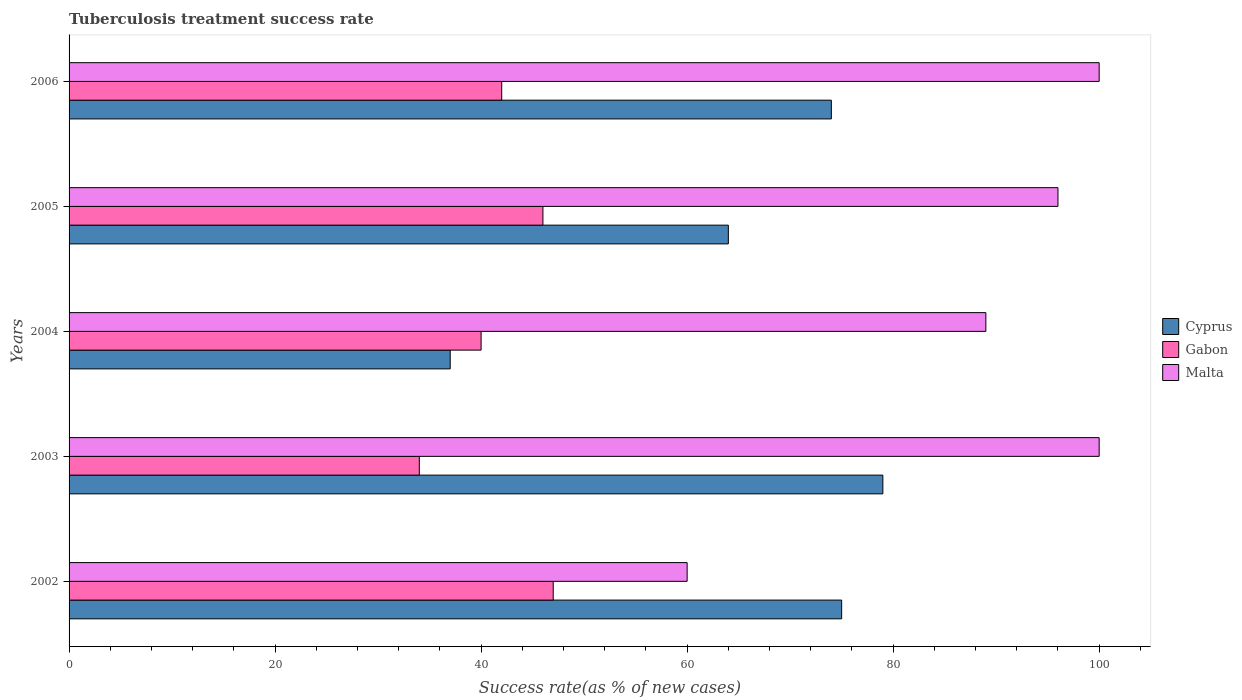How many different coloured bars are there?
Ensure brevity in your answer.  3. How many groups of bars are there?
Offer a terse response. 5. What is the label of the 2nd group of bars from the top?
Make the answer very short. 2005. What is the tuberculosis treatment success rate in Gabon in 2006?
Your answer should be compact. 42. Across all years, what is the maximum tuberculosis treatment success rate in Malta?
Offer a terse response. 100. Across all years, what is the minimum tuberculosis treatment success rate in Cyprus?
Provide a succinct answer. 37. What is the total tuberculosis treatment success rate in Malta in the graph?
Ensure brevity in your answer.  445. What is the average tuberculosis treatment success rate in Cyprus per year?
Offer a terse response. 65.8. In the year 2003, what is the difference between the tuberculosis treatment success rate in Gabon and tuberculosis treatment success rate in Malta?
Offer a terse response. -66. In how many years, is the tuberculosis treatment success rate in Gabon greater than 92 %?
Your answer should be compact. 0. What is the ratio of the tuberculosis treatment success rate in Gabon in 2004 to that in 2006?
Your answer should be very brief. 0.95. Is the tuberculosis treatment success rate in Cyprus in 2002 less than that in 2004?
Offer a very short reply. No. Is the difference between the tuberculosis treatment success rate in Gabon in 2002 and 2005 greater than the difference between the tuberculosis treatment success rate in Malta in 2002 and 2005?
Your answer should be very brief. Yes. In how many years, is the tuberculosis treatment success rate in Gabon greater than the average tuberculosis treatment success rate in Gabon taken over all years?
Provide a short and direct response. 3. What does the 2nd bar from the top in 2004 represents?
Your response must be concise. Gabon. What does the 1st bar from the bottom in 2003 represents?
Your response must be concise. Cyprus. How many bars are there?
Provide a short and direct response. 15. How many years are there in the graph?
Provide a short and direct response. 5. What is the difference between two consecutive major ticks on the X-axis?
Provide a succinct answer. 20. Are the values on the major ticks of X-axis written in scientific E-notation?
Provide a succinct answer. No. Does the graph contain grids?
Offer a very short reply. No. Where does the legend appear in the graph?
Provide a short and direct response. Center right. How many legend labels are there?
Give a very brief answer. 3. What is the title of the graph?
Your answer should be compact. Tuberculosis treatment success rate. What is the label or title of the X-axis?
Your response must be concise. Success rate(as % of new cases). What is the label or title of the Y-axis?
Offer a very short reply. Years. What is the Success rate(as % of new cases) in Cyprus in 2002?
Provide a short and direct response. 75. What is the Success rate(as % of new cases) of Cyprus in 2003?
Provide a short and direct response. 79. What is the Success rate(as % of new cases) in Cyprus in 2004?
Your response must be concise. 37. What is the Success rate(as % of new cases) of Malta in 2004?
Offer a very short reply. 89. What is the Success rate(as % of new cases) of Cyprus in 2005?
Give a very brief answer. 64. What is the Success rate(as % of new cases) in Malta in 2005?
Keep it short and to the point. 96. What is the Success rate(as % of new cases) in Cyprus in 2006?
Ensure brevity in your answer.  74. What is the Success rate(as % of new cases) in Malta in 2006?
Ensure brevity in your answer.  100. Across all years, what is the maximum Success rate(as % of new cases) of Cyprus?
Give a very brief answer. 79. Across all years, what is the maximum Success rate(as % of new cases) in Gabon?
Offer a very short reply. 47. Across all years, what is the minimum Success rate(as % of new cases) of Gabon?
Provide a short and direct response. 34. Across all years, what is the minimum Success rate(as % of new cases) in Malta?
Offer a terse response. 60. What is the total Success rate(as % of new cases) in Cyprus in the graph?
Your response must be concise. 329. What is the total Success rate(as % of new cases) in Gabon in the graph?
Your answer should be compact. 209. What is the total Success rate(as % of new cases) in Malta in the graph?
Your answer should be compact. 445. What is the difference between the Success rate(as % of new cases) in Cyprus in 2002 and that in 2003?
Your answer should be compact. -4. What is the difference between the Success rate(as % of new cases) of Gabon in 2002 and that in 2003?
Provide a succinct answer. 13. What is the difference between the Success rate(as % of new cases) in Cyprus in 2002 and that in 2004?
Your response must be concise. 38. What is the difference between the Success rate(as % of new cases) in Malta in 2002 and that in 2004?
Provide a short and direct response. -29. What is the difference between the Success rate(as % of new cases) of Cyprus in 2002 and that in 2005?
Your answer should be compact. 11. What is the difference between the Success rate(as % of new cases) in Gabon in 2002 and that in 2005?
Your answer should be very brief. 1. What is the difference between the Success rate(as % of new cases) in Malta in 2002 and that in 2005?
Ensure brevity in your answer.  -36. What is the difference between the Success rate(as % of new cases) in Cyprus in 2002 and that in 2006?
Offer a very short reply. 1. What is the difference between the Success rate(as % of new cases) of Gabon in 2002 and that in 2006?
Give a very brief answer. 5. What is the difference between the Success rate(as % of new cases) in Cyprus in 2003 and that in 2004?
Make the answer very short. 42. What is the difference between the Success rate(as % of new cases) of Cyprus in 2003 and that in 2005?
Make the answer very short. 15. What is the difference between the Success rate(as % of new cases) in Gabon in 2003 and that in 2005?
Offer a very short reply. -12. What is the difference between the Success rate(as % of new cases) of Malta in 2003 and that in 2005?
Offer a terse response. 4. What is the difference between the Success rate(as % of new cases) in Gabon in 2003 and that in 2006?
Keep it short and to the point. -8. What is the difference between the Success rate(as % of new cases) of Malta in 2003 and that in 2006?
Offer a terse response. 0. What is the difference between the Success rate(as % of new cases) in Cyprus in 2004 and that in 2005?
Your answer should be very brief. -27. What is the difference between the Success rate(as % of new cases) in Malta in 2004 and that in 2005?
Provide a short and direct response. -7. What is the difference between the Success rate(as % of new cases) of Cyprus in 2004 and that in 2006?
Keep it short and to the point. -37. What is the difference between the Success rate(as % of new cases) in Gabon in 2004 and that in 2006?
Make the answer very short. -2. What is the difference between the Success rate(as % of new cases) of Malta in 2004 and that in 2006?
Give a very brief answer. -11. What is the difference between the Success rate(as % of new cases) of Malta in 2005 and that in 2006?
Your answer should be compact. -4. What is the difference between the Success rate(as % of new cases) in Cyprus in 2002 and the Success rate(as % of new cases) in Gabon in 2003?
Ensure brevity in your answer.  41. What is the difference between the Success rate(as % of new cases) of Cyprus in 2002 and the Success rate(as % of new cases) of Malta in 2003?
Your answer should be very brief. -25. What is the difference between the Success rate(as % of new cases) of Gabon in 2002 and the Success rate(as % of new cases) of Malta in 2003?
Your answer should be compact. -53. What is the difference between the Success rate(as % of new cases) in Cyprus in 2002 and the Success rate(as % of new cases) in Gabon in 2004?
Ensure brevity in your answer.  35. What is the difference between the Success rate(as % of new cases) of Gabon in 2002 and the Success rate(as % of new cases) of Malta in 2004?
Provide a succinct answer. -42. What is the difference between the Success rate(as % of new cases) of Cyprus in 2002 and the Success rate(as % of new cases) of Gabon in 2005?
Make the answer very short. 29. What is the difference between the Success rate(as % of new cases) in Gabon in 2002 and the Success rate(as % of new cases) in Malta in 2005?
Keep it short and to the point. -49. What is the difference between the Success rate(as % of new cases) of Cyprus in 2002 and the Success rate(as % of new cases) of Gabon in 2006?
Your answer should be very brief. 33. What is the difference between the Success rate(as % of new cases) of Gabon in 2002 and the Success rate(as % of new cases) of Malta in 2006?
Your response must be concise. -53. What is the difference between the Success rate(as % of new cases) in Cyprus in 2003 and the Success rate(as % of new cases) in Gabon in 2004?
Keep it short and to the point. 39. What is the difference between the Success rate(as % of new cases) in Gabon in 2003 and the Success rate(as % of new cases) in Malta in 2004?
Provide a succinct answer. -55. What is the difference between the Success rate(as % of new cases) in Cyprus in 2003 and the Success rate(as % of new cases) in Gabon in 2005?
Offer a very short reply. 33. What is the difference between the Success rate(as % of new cases) of Cyprus in 2003 and the Success rate(as % of new cases) of Malta in 2005?
Give a very brief answer. -17. What is the difference between the Success rate(as % of new cases) of Gabon in 2003 and the Success rate(as % of new cases) of Malta in 2005?
Your response must be concise. -62. What is the difference between the Success rate(as % of new cases) of Cyprus in 2003 and the Success rate(as % of new cases) of Malta in 2006?
Your answer should be compact. -21. What is the difference between the Success rate(as % of new cases) of Gabon in 2003 and the Success rate(as % of new cases) of Malta in 2006?
Your answer should be compact. -66. What is the difference between the Success rate(as % of new cases) of Cyprus in 2004 and the Success rate(as % of new cases) of Malta in 2005?
Your response must be concise. -59. What is the difference between the Success rate(as % of new cases) in Gabon in 2004 and the Success rate(as % of new cases) in Malta in 2005?
Provide a succinct answer. -56. What is the difference between the Success rate(as % of new cases) in Cyprus in 2004 and the Success rate(as % of new cases) in Gabon in 2006?
Offer a very short reply. -5. What is the difference between the Success rate(as % of new cases) in Cyprus in 2004 and the Success rate(as % of new cases) in Malta in 2006?
Keep it short and to the point. -63. What is the difference between the Success rate(as % of new cases) of Gabon in 2004 and the Success rate(as % of new cases) of Malta in 2006?
Ensure brevity in your answer.  -60. What is the difference between the Success rate(as % of new cases) in Cyprus in 2005 and the Success rate(as % of new cases) in Gabon in 2006?
Ensure brevity in your answer.  22. What is the difference between the Success rate(as % of new cases) in Cyprus in 2005 and the Success rate(as % of new cases) in Malta in 2006?
Your response must be concise. -36. What is the difference between the Success rate(as % of new cases) of Gabon in 2005 and the Success rate(as % of new cases) of Malta in 2006?
Provide a short and direct response. -54. What is the average Success rate(as % of new cases) of Cyprus per year?
Ensure brevity in your answer.  65.8. What is the average Success rate(as % of new cases) of Gabon per year?
Provide a succinct answer. 41.8. What is the average Success rate(as % of new cases) in Malta per year?
Your answer should be compact. 89. In the year 2002, what is the difference between the Success rate(as % of new cases) in Cyprus and Success rate(as % of new cases) in Malta?
Ensure brevity in your answer.  15. In the year 2002, what is the difference between the Success rate(as % of new cases) in Gabon and Success rate(as % of new cases) in Malta?
Your answer should be compact. -13. In the year 2003, what is the difference between the Success rate(as % of new cases) of Gabon and Success rate(as % of new cases) of Malta?
Ensure brevity in your answer.  -66. In the year 2004, what is the difference between the Success rate(as % of new cases) in Cyprus and Success rate(as % of new cases) in Malta?
Your answer should be very brief. -52. In the year 2004, what is the difference between the Success rate(as % of new cases) of Gabon and Success rate(as % of new cases) of Malta?
Your answer should be very brief. -49. In the year 2005, what is the difference between the Success rate(as % of new cases) of Cyprus and Success rate(as % of new cases) of Malta?
Provide a succinct answer. -32. In the year 2006, what is the difference between the Success rate(as % of new cases) of Cyprus and Success rate(as % of new cases) of Gabon?
Your response must be concise. 32. In the year 2006, what is the difference between the Success rate(as % of new cases) of Gabon and Success rate(as % of new cases) of Malta?
Keep it short and to the point. -58. What is the ratio of the Success rate(as % of new cases) of Cyprus in 2002 to that in 2003?
Keep it short and to the point. 0.95. What is the ratio of the Success rate(as % of new cases) in Gabon in 2002 to that in 2003?
Give a very brief answer. 1.38. What is the ratio of the Success rate(as % of new cases) in Malta in 2002 to that in 2003?
Offer a very short reply. 0.6. What is the ratio of the Success rate(as % of new cases) of Cyprus in 2002 to that in 2004?
Make the answer very short. 2.03. What is the ratio of the Success rate(as % of new cases) of Gabon in 2002 to that in 2004?
Keep it short and to the point. 1.18. What is the ratio of the Success rate(as % of new cases) of Malta in 2002 to that in 2004?
Keep it short and to the point. 0.67. What is the ratio of the Success rate(as % of new cases) of Cyprus in 2002 to that in 2005?
Your response must be concise. 1.17. What is the ratio of the Success rate(as % of new cases) in Gabon in 2002 to that in 2005?
Provide a short and direct response. 1.02. What is the ratio of the Success rate(as % of new cases) in Malta in 2002 to that in 2005?
Your answer should be compact. 0.62. What is the ratio of the Success rate(as % of new cases) in Cyprus in 2002 to that in 2006?
Provide a short and direct response. 1.01. What is the ratio of the Success rate(as % of new cases) in Gabon in 2002 to that in 2006?
Your answer should be very brief. 1.12. What is the ratio of the Success rate(as % of new cases) of Malta in 2002 to that in 2006?
Make the answer very short. 0.6. What is the ratio of the Success rate(as % of new cases) in Cyprus in 2003 to that in 2004?
Your answer should be very brief. 2.14. What is the ratio of the Success rate(as % of new cases) in Gabon in 2003 to that in 2004?
Provide a short and direct response. 0.85. What is the ratio of the Success rate(as % of new cases) in Malta in 2003 to that in 2004?
Provide a short and direct response. 1.12. What is the ratio of the Success rate(as % of new cases) of Cyprus in 2003 to that in 2005?
Your response must be concise. 1.23. What is the ratio of the Success rate(as % of new cases) in Gabon in 2003 to that in 2005?
Keep it short and to the point. 0.74. What is the ratio of the Success rate(as % of new cases) of Malta in 2003 to that in 2005?
Your response must be concise. 1.04. What is the ratio of the Success rate(as % of new cases) of Cyprus in 2003 to that in 2006?
Your answer should be very brief. 1.07. What is the ratio of the Success rate(as % of new cases) of Gabon in 2003 to that in 2006?
Offer a terse response. 0.81. What is the ratio of the Success rate(as % of new cases) in Malta in 2003 to that in 2006?
Your answer should be compact. 1. What is the ratio of the Success rate(as % of new cases) in Cyprus in 2004 to that in 2005?
Your answer should be very brief. 0.58. What is the ratio of the Success rate(as % of new cases) of Gabon in 2004 to that in 2005?
Give a very brief answer. 0.87. What is the ratio of the Success rate(as % of new cases) of Malta in 2004 to that in 2005?
Ensure brevity in your answer.  0.93. What is the ratio of the Success rate(as % of new cases) of Cyprus in 2004 to that in 2006?
Offer a terse response. 0.5. What is the ratio of the Success rate(as % of new cases) in Malta in 2004 to that in 2006?
Provide a short and direct response. 0.89. What is the ratio of the Success rate(as % of new cases) of Cyprus in 2005 to that in 2006?
Your response must be concise. 0.86. What is the ratio of the Success rate(as % of new cases) in Gabon in 2005 to that in 2006?
Offer a terse response. 1.1. What is the ratio of the Success rate(as % of new cases) of Malta in 2005 to that in 2006?
Your response must be concise. 0.96. What is the difference between the highest and the second highest Success rate(as % of new cases) of Cyprus?
Your answer should be very brief. 4. What is the difference between the highest and the second highest Success rate(as % of new cases) in Gabon?
Your answer should be very brief. 1. What is the difference between the highest and the second highest Success rate(as % of new cases) of Malta?
Provide a short and direct response. 0. What is the difference between the highest and the lowest Success rate(as % of new cases) of Cyprus?
Your answer should be compact. 42. What is the difference between the highest and the lowest Success rate(as % of new cases) of Gabon?
Give a very brief answer. 13. 